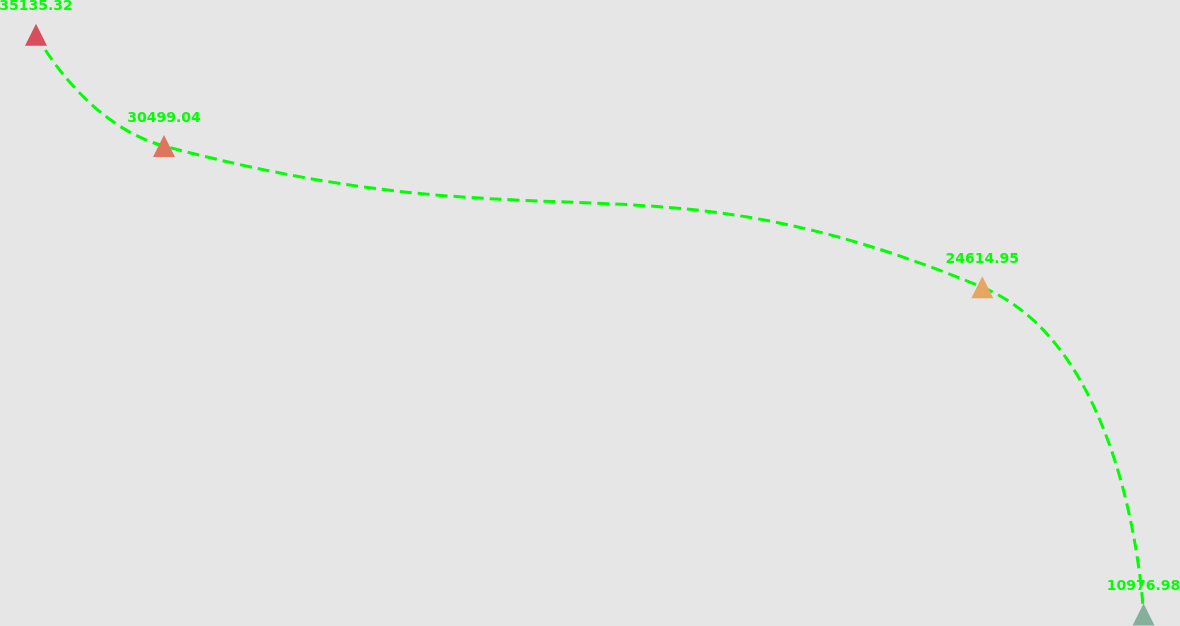Convert chart to OTSL. <chart><loc_0><loc_0><loc_500><loc_500><line_chart><ecel><fcel>Unnamed: 1<nl><fcel>1831.53<fcel>35135.3<nl><fcel>1874.94<fcel>30499<nl><fcel>2152.45<fcel>24615<nl><fcel>2207.13<fcel>10977<nl><fcel>2265.61<fcel>6105.62<nl></chart> 